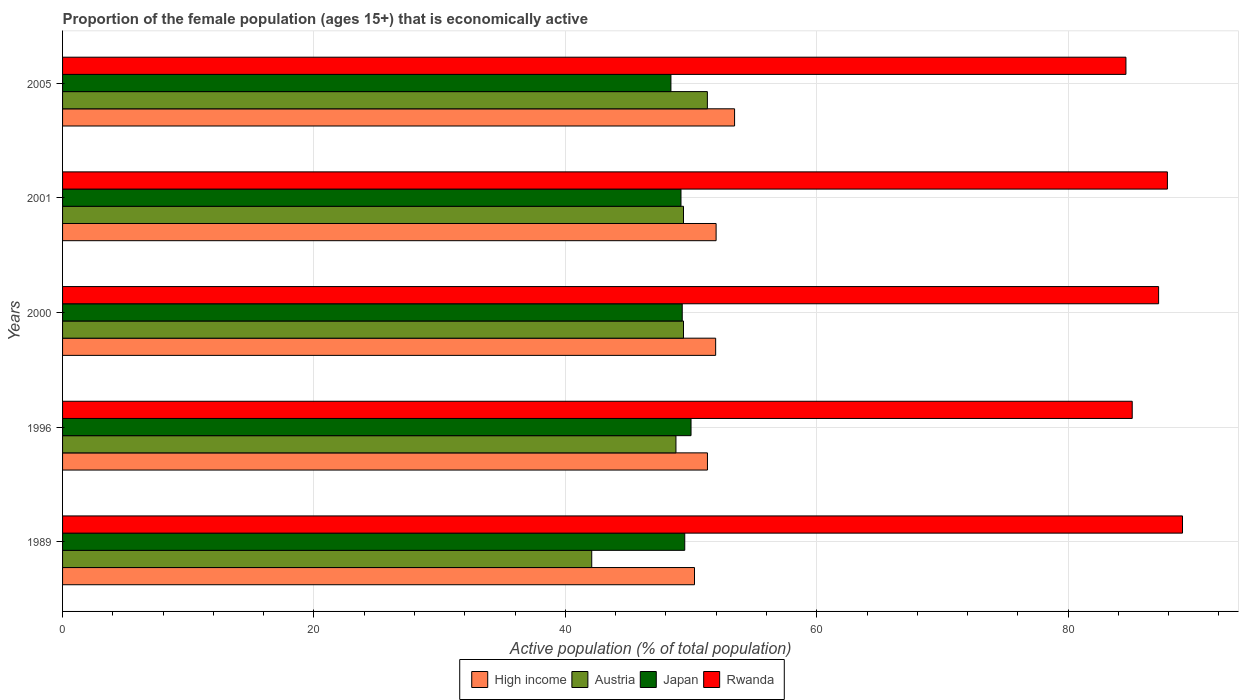How many different coloured bars are there?
Give a very brief answer. 4. How many bars are there on the 1st tick from the top?
Your response must be concise. 4. How many bars are there on the 5th tick from the bottom?
Offer a very short reply. 4. What is the proportion of the female population that is economically active in High income in 2000?
Ensure brevity in your answer.  51.96. Across all years, what is the maximum proportion of the female population that is economically active in Rwanda?
Offer a very short reply. 89.1. Across all years, what is the minimum proportion of the female population that is economically active in Rwanda?
Make the answer very short. 84.6. In which year was the proportion of the female population that is economically active in Austria maximum?
Give a very brief answer. 2005. What is the total proportion of the female population that is economically active in Austria in the graph?
Ensure brevity in your answer.  241. What is the difference between the proportion of the female population that is economically active in Austria in 1996 and that in 2000?
Make the answer very short. -0.6. What is the difference between the proportion of the female population that is economically active in Japan in 1996 and the proportion of the female population that is economically active in Rwanda in 1989?
Ensure brevity in your answer.  -39.1. What is the average proportion of the female population that is economically active in Austria per year?
Make the answer very short. 48.2. In the year 2000, what is the difference between the proportion of the female population that is economically active in High income and proportion of the female population that is economically active in Austria?
Your answer should be very brief. 2.56. In how many years, is the proportion of the female population that is economically active in Austria greater than 40 %?
Make the answer very short. 5. What is the ratio of the proportion of the female population that is economically active in High income in 1996 to that in 2001?
Your answer should be very brief. 0.99. Is the proportion of the female population that is economically active in High income in 2001 less than that in 2005?
Your answer should be compact. Yes. Is the difference between the proportion of the female population that is economically active in High income in 1996 and 2000 greater than the difference between the proportion of the female population that is economically active in Austria in 1996 and 2000?
Provide a short and direct response. No. What is the difference between the highest and the second highest proportion of the female population that is economically active in Rwanda?
Provide a short and direct response. 1.2. What is the difference between the highest and the lowest proportion of the female population that is economically active in Japan?
Your answer should be very brief. 1.6. In how many years, is the proportion of the female population that is economically active in Rwanda greater than the average proportion of the female population that is economically active in Rwanda taken over all years?
Offer a terse response. 3. Is it the case that in every year, the sum of the proportion of the female population that is economically active in Austria and proportion of the female population that is economically active in Japan is greater than the sum of proportion of the female population that is economically active in High income and proportion of the female population that is economically active in Rwanda?
Give a very brief answer. No. What does the 1st bar from the top in 2001 represents?
Give a very brief answer. Rwanda. What does the 3rd bar from the bottom in 1989 represents?
Give a very brief answer. Japan. Is it the case that in every year, the sum of the proportion of the female population that is economically active in Japan and proportion of the female population that is economically active in Rwanda is greater than the proportion of the female population that is economically active in High income?
Give a very brief answer. Yes. Are the values on the major ticks of X-axis written in scientific E-notation?
Ensure brevity in your answer.  No. How many legend labels are there?
Your answer should be very brief. 4. What is the title of the graph?
Provide a short and direct response. Proportion of the female population (ages 15+) that is economically active. Does "Gambia, The" appear as one of the legend labels in the graph?
Make the answer very short. No. What is the label or title of the X-axis?
Your answer should be compact. Active population (% of total population). What is the Active population (% of total population) in High income in 1989?
Provide a short and direct response. 50.28. What is the Active population (% of total population) in Austria in 1989?
Ensure brevity in your answer.  42.1. What is the Active population (% of total population) of Japan in 1989?
Your answer should be very brief. 49.5. What is the Active population (% of total population) in Rwanda in 1989?
Ensure brevity in your answer.  89.1. What is the Active population (% of total population) of High income in 1996?
Offer a terse response. 51.31. What is the Active population (% of total population) in Austria in 1996?
Keep it short and to the point. 48.8. What is the Active population (% of total population) of Rwanda in 1996?
Offer a terse response. 85.1. What is the Active population (% of total population) of High income in 2000?
Your answer should be very brief. 51.96. What is the Active population (% of total population) in Austria in 2000?
Your response must be concise. 49.4. What is the Active population (% of total population) of Japan in 2000?
Your answer should be compact. 49.3. What is the Active population (% of total population) in Rwanda in 2000?
Keep it short and to the point. 87.2. What is the Active population (% of total population) of High income in 2001?
Give a very brief answer. 51.99. What is the Active population (% of total population) of Austria in 2001?
Make the answer very short. 49.4. What is the Active population (% of total population) in Japan in 2001?
Offer a very short reply. 49.2. What is the Active population (% of total population) of Rwanda in 2001?
Provide a short and direct response. 87.9. What is the Active population (% of total population) of High income in 2005?
Your response must be concise. 53.46. What is the Active population (% of total population) in Austria in 2005?
Offer a very short reply. 51.3. What is the Active population (% of total population) of Japan in 2005?
Ensure brevity in your answer.  48.4. What is the Active population (% of total population) of Rwanda in 2005?
Offer a terse response. 84.6. Across all years, what is the maximum Active population (% of total population) of High income?
Your answer should be compact. 53.46. Across all years, what is the maximum Active population (% of total population) of Austria?
Ensure brevity in your answer.  51.3. Across all years, what is the maximum Active population (% of total population) of Rwanda?
Offer a very short reply. 89.1. Across all years, what is the minimum Active population (% of total population) in High income?
Provide a short and direct response. 50.28. Across all years, what is the minimum Active population (% of total population) of Austria?
Ensure brevity in your answer.  42.1. Across all years, what is the minimum Active population (% of total population) of Japan?
Offer a very short reply. 48.4. Across all years, what is the minimum Active population (% of total population) in Rwanda?
Make the answer very short. 84.6. What is the total Active population (% of total population) of High income in the graph?
Ensure brevity in your answer.  259. What is the total Active population (% of total population) in Austria in the graph?
Provide a short and direct response. 241. What is the total Active population (% of total population) of Japan in the graph?
Provide a succinct answer. 246.4. What is the total Active population (% of total population) in Rwanda in the graph?
Offer a very short reply. 433.9. What is the difference between the Active population (% of total population) of High income in 1989 and that in 1996?
Provide a succinct answer. -1.03. What is the difference between the Active population (% of total population) in Austria in 1989 and that in 1996?
Keep it short and to the point. -6.7. What is the difference between the Active population (% of total population) of High income in 1989 and that in 2000?
Offer a terse response. -1.68. What is the difference between the Active population (% of total population) in Rwanda in 1989 and that in 2000?
Make the answer very short. 1.9. What is the difference between the Active population (% of total population) in High income in 1989 and that in 2001?
Offer a very short reply. -1.72. What is the difference between the Active population (% of total population) in Austria in 1989 and that in 2001?
Your response must be concise. -7.3. What is the difference between the Active population (% of total population) in High income in 1989 and that in 2005?
Keep it short and to the point. -3.19. What is the difference between the Active population (% of total population) of Austria in 1989 and that in 2005?
Keep it short and to the point. -9.2. What is the difference between the Active population (% of total population) in Japan in 1989 and that in 2005?
Provide a succinct answer. 1.1. What is the difference between the Active population (% of total population) in High income in 1996 and that in 2000?
Your response must be concise. -0.65. What is the difference between the Active population (% of total population) in Austria in 1996 and that in 2000?
Ensure brevity in your answer.  -0.6. What is the difference between the Active population (% of total population) of Japan in 1996 and that in 2000?
Your answer should be compact. 0.7. What is the difference between the Active population (% of total population) of High income in 1996 and that in 2001?
Your answer should be compact. -0.69. What is the difference between the Active population (% of total population) of Austria in 1996 and that in 2001?
Make the answer very short. -0.6. What is the difference between the Active population (% of total population) of Japan in 1996 and that in 2001?
Give a very brief answer. 0.8. What is the difference between the Active population (% of total population) of High income in 1996 and that in 2005?
Offer a very short reply. -2.16. What is the difference between the Active population (% of total population) of Austria in 1996 and that in 2005?
Keep it short and to the point. -2.5. What is the difference between the Active population (% of total population) of Rwanda in 1996 and that in 2005?
Provide a succinct answer. 0.5. What is the difference between the Active population (% of total population) of High income in 2000 and that in 2001?
Provide a succinct answer. -0.04. What is the difference between the Active population (% of total population) in Austria in 2000 and that in 2001?
Offer a very short reply. 0. What is the difference between the Active population (% of total population) in Rwanda in 2000 and that in 2001?
Offer a very short reply. -0.7. What is the difference between the Active population (% of total population) of High income in 2000 and that in 2005?
Your answer should be very brief. -1.51. What is the difference between the Active population (% of total population) of High income in 2001 and that in 2005?
Give a very brief answer. -1.47. What is the difference between the Active population (% of total population) of High income in 1989 and the Active population (% of total population) of Austria in 1996?
Your answer should be compact. 1.48. What is the difference between the Active population (% of total population) in High income in 1989 and the Active population (% of total population) in Japan in 1996?
Provide a succinct answer. 0.28. What is the difference between the Active population (% of total population) of High income in 1989 and the Active population (% of total population) of Rwanda in 1996?
Provide a succinct answer. -34.82. What is the difference between the Active population (% of total population) in Austria in 1989 and the Active population (% of total population) in Japan in 1996?
Give a very brief answer. -7.9. What is the difference between the Active population (% of total population) of Austria in 1989 and the Active population (% of total population) of Rwanda in 1996?
Your response must be concise. -43. What is the difference between the Active population (% of total population) of Japan in 1989 and the Active population (% of total population) of Rwanda in 1996?
Ensure brevity in your answer.  -35.6. What is the difference between the Active population (% of total population) in High income in 1989 and the Active population (% of total population) in Austria in 2000?
Provide a succinct answer. 0.88. What is the difference between the Active population (% of total population) of High income in 1989 and the Active population (% of total population) of Japan in 2000?
Provide a succinct answer. 0.98. What is the difference between the Active population (% of total population) in High income in 1989 and the Active population (% of total population) in Rwanda in 2000?
Your answer should be compact. -36.92. What is the difference between the Active population (% of total population) in Austria in 1989 and the Active population (% of total population) in Rwanda in 2000?
Ensure brevity in your answer.  -45.1. What is the difference between the Active population (% of total population) of Japan in 1989 and the Active population (% of total population) of Rwanda in 2000?
Ensure brevity in your answer.  -37.7. What is the difference between the Active population (% of total population) of High income in 1989 and the Active population (% of total population) of Austria in 2001?
Your response must be concise. 0.88. What is the difference between the Active population (% of total population) in High income in 1989 and the Active population (% of total population) in Japan in 2001?
Give a very brief answer. 1.08. What is the difference between the Active population (% of total population) in High income in 1989 and the Active population (% of total population) in Rwanda in 2001?
Make the answer very short. -37.62. What is the difference between the Active population (% of total population) in Austria in 1989 and the Active population (% of total population) in Japan in 2001?
Provide a short and direct response. -7.1. What is the difference between the Active population (% of total population) in Austria in 1989 and the Active population (% of total population) in Rwanda in 2001?
Provide a short and direct response. -45.8. What is the difference between the Active population (% of total population) of Japan in 1989 and the Active population (% of total population) of Rwanda in 2001?
Give a very brief answer. -38.4. What is the difference between the Active population (% of total population) of High income in 1989 and the Active population (% of total population) of Austria in 2005?
Your response must be concise. -1.02. What is the difference between the Active population (% of total population) of High income in 1989 and the Active population (% of total population) of Japan in 2005?
Ensure brevity in your answer.  1.88. What is the difference between the Active population (% of total population) of High income in 1989 and the Active population (% of total population) of Rwanda in 2005?
Provide a short and direct response. -34.32. What is the difference between the Active population (% of total population) of Austria in 1989 and the Active population (% of total population) of Rwanda in 2005?
Your answer should be compact. -42.5. What is the difference between the Active population (% of total population) of Japan in 1989 and the Active population (% of total population) of Rwanda in 2005?
Keep it short and to the point. -35.1. What is the difference between the Active population (% of total population) of High income in 1996 and the Active population (% of total population) of Austria in 2000?
Make the answer very short. 1.91. What is the difference between the Active population (% of total population) of High income in 1996 and the Active population (% of total population) of Japan in 2000?
Give a very brief answer. 2.01. What is the difference between the Active population (% of total population) in High income in 1996 and the Active population (% of total population) in Rwanda in 2000?
Your answer should be very brief. -35.89. What is the difference between the Active population (% of total population) in Austria in 1996 and the Active population (% of total population) in Rwanda in 2000?
Your answer should be very brief. -38.4. What is the difference between the Active population (% of total population) of Japan in 1996 and the Active population (% of total population) of Rwanda in 2000?
Make the answer very short. -37.2. What is the difference between the Active population (% of total population) in High income in 1996 and the Active population (% of total population) in Austria in 2001?
Offer a very short reply. 1.91. What is the difference between the Active population (% of total population) in High income in 1996 and the Active population (% of total population) in Japan in 2001?
Your response must be concise. 2.11. What is the difference between the Active population (% of total population) in High income in 1996 and the Active population (% of total population) in Rwanda in 2001?
Offer a very short reply. -36.59. What is the difference between the Active population (% of total population) of Austria in 1996 and the Active population (% of total population) of Rwanda in 2001?
Provide a succinct answer. -39.1. What is the difference between the Active population (% of total population) in Japan in 1996 and the Active population (% of total population) in Rwanda in 2001?
Give a very brief answer. -37.9. What is the difference between the Active population (% of total population) of High income in 1996 and the Active population (% of total population) of Austria in 2005?
Offer a very short reply. 0.01. What is the difference between the Active population (% of total population) of High income in 1996 and the Active population (% of total population) of Japan in 2005?
Make the answer very short. 2.91. What is the difference between the Active population (% of total population) of High income in 1996 and the Active population (% of total population) of Rwanda in 2005?
Offer a terse response. -33.29. What is the difference between the Active population (% of total population) of Austria in 1996 and the Active population (% of total population) of Japan in 2005?
Give a very brief answer. 0.4. What is the difference between the Active population (% of total population) in Austria in 1996 and the Active population (% of total population) in Rwanda in 2005?
Provide a succinct answer. -35.8. What is the difference between the Active population (% of total population) in Japan in 1996 and the Active population (% of total population) in Rwanda in 2005?
Give a very brief answer. -34.6. What is the difference between the Active population (% of total population) in High income in 2000 and the Active population (% of total population) in Austria in 2001?
Offer a very short reply. 2.56. What is the difference between the Active population (% of total population) in High income in 2000 and the Active population (% of total population) in Japan in 2001?
Give a very brief answer. 2.76. What is the difference between the Active population (% of total population) in High income in 2000 and the Active population (% of total population) in Rwanda in 2001?
Keep it short and to the point. -35.94. What is the difference between the Active population (% of total population) of Austria in 2000 and the Active population (% of total population) of Japan in 2001?
Give a very brief answer. 0.2. What is the difference between the Active population (% of total population) of Austria in 2000 and the Active population (% of total population) of Rwanda in 2001?
Make the answer very short. -38.5. What is the difference between the Active population (% of total population) of Japan in 2000 and the Active population (% of total population) of Rwanda in 2001?
Make the answer very short. -38.6. What is the difference between the Active population (% of total population) in High income in 2000 and the Active population (% of total population) in Austria in 2005?
Make the answer very short. 0.66. What is the difference between the Active population (% of total population) in High income in 2000 and the Active population (% of total population) in Japan in 2005?
Provide a short and direct response. 3.56. What is the difference between the Active population (% of total population) of High income in 2000 and the Active population (% of total population) of Rwanda in 2005?
Ensure brevity in your answer.  -32.64. What is the difference between the Active population (% of total population) of Austria in 2000 and the Active population (% of total population) of Japan in 2005?
Give a very brief answer. 1. What is the difference between the Active population (% of total population) in Austria in 2000 and the Active population (% of total population) in Rwanda in 2005?
Provide a succinct answer. -35.2. What is the difference between the Active population (% of total population) in Japan in 2000 and the Active population (% of total population) in Rwanda in 2005?
Offer a terse response. -35.3. What is the difference between the Active population (% of total population) of High income in 2001 and the Active population (% of total population) of Austria in 2005?
Make the answer very short. 0.69. What is the difference between the Active population (% of total population) of High income in 2001 and the Active population (% of total population) of Japan in 2005?
Ensure brevity in your answer.  3.59. What is the difference between the Active population (% of total population) of High income in 2001 and the Active population (% of total population) of Rwanda in 2005?
Your answer should be very brief. -32.61. What is the difference between the Active population (% of total population) in Austria in 2001 and the Active population (% of total population) in Japan in 2005?
Ensure brevity in your answer.  1. What is the difference between the Active population (% of total population) in Austria in 2001 and the Active population (% of total population) in Rwanda in 2005?
Keep it short and to the point. -35.2. What is the difference between the Active population (% of total population) of Japan in 2001 and the Active population (% of total population) of Rwanda in 2005?
Make the answer very short. -35.4. What is the average Active population (% of total population) in High income per year?
Your answer should be very brief. 51.8. What is the average Active population (% of total population) of Austria per year?
Your response must be concise. 48.2. What is the average Active population (% of total population) of Japan per year?
Make the answer very short. 49.28. What is the average Active population (% of total population) in Rwanda per year?
Give a very brief answer. 86.78. In the year 1989, what is the difference between the Active population (% of total population) of High income and Active population (% of total population) of Austria?
Ensure brevity in your answer.  8.18. In the year 1989, what is the difference between the Active population (% of total population) in High income and Active population (% of total population) in Japan?
Give a very brief answer. 0.78. In the year 1989, what is the difference between the Active population (% of total population) in High income and Active population (% of total population) in Rwanda?
Offer a terse response. -38.82. In the year 1989, what is the difference between the Active population (% of total population) of Austria and Active population (% of total population) of Rwanda?
Provide a succinct answer. -47. In the year 1989, what is the difference between the Active population (% of total population) in Japan and Active population (% of total population) in Rwanda?
Offer a very short reply. -39.6. In the year 1996, what is the difference between the Active population (% of total population) in High income and Active population (% of total population) in Austria?
Your answer should be very brief. 2.51. In the year 1996, what is the difference between the Active population (% of total population) in High income and Active population (% of total population) in Japan?
Offer a terse response. 1.31. In the year 1996, what is the difference between the Active population (% of total population) of High income and Active population (% of total population) of Rwanda?
Keep it short and to the point. -33.79. In the year 1996, what is the difference between the Active population (% of total population) in Austria and Active population (% of total population) in Japan?
Provide a succinct answer. -1.2. In the year 1996, what is the difference between the Active population (% of total population) of Austria and Active population (% of total population) of Rwanda?
Offer a terse response. -36.3. In the year 1996, what is the difference between the Active population (% of total population) in Japan and Active population (% of total population) in Rwanda?
Offer a very short reply. -35.1. In the year 2000, what is the difference between the Active population (% of total population) in High income and Active population (% of total population) in Austria?
Make the answer very short. 2.56. In the year 2000, what is the difference between the Active population (% of total population) of High income and Active population (% of total population) of Japan?
Ensure brevity in your answer.  2.66. In the year 2000, what is the difference between the Active population (% of total population) in High income and Active population (% of total population) in Rwanda?
Keep it short and to the point. -35.24. In the year 2000, what is the difference between the Active population (% of total population) in Austria and Active population (% of total population) in Rwanda?
Your answer should be compact. -37.8. In the year 2000, what is the difference between the Active population (% of total population) of Japan and Active population (% of total population) of Rwanda?
Make the answer very short. -37.9. In the year 2001, what is the difference between the Active population (% of total population) of High income and Active population (% of total population) of Austria?
Offer a terse response. 2.59. In the year 2001, what is the difference between the Active population (% of total population) of High income and Active population (% of total population) of Japan?
Your answer should be compact. 2.79. In the year 2001, what is the difference between the Active population (% of total population) in High income and Active population (% of total population) in Rwanda?
Provide a short and direct response. -35.91. In the year 2001, what is the difference between the Active population (% of total population) in Austria and Active population (% of total population) in Rwanda?
Keep it short and to the point. -38.5. In the year 2001, what is the difference between the Active population (% of total population) in Japan and Active population (% of total population) in Rwanda?
Provide a succinct answer. -38.7. In the year 2005, what is the difference between the Active population (% of total population) of High income and Active population (% of total population) of Austria?
Ensure brevity in your answer.  2.16. In the year 2005, what is the difference between the Active population (% of total population) in High income and Active population (% of total population) in Japan?
Ensure brevity in your answer.  5.06. In the year 2005, what is the difference between the Active population (% of total population) in High income and Active population (% of total population) in Rwanda?
Your answer should be compact. -31.14. In the year 2005, what is the difference between the Active population (% of total population) in Austria and Active population (% of total population) in Japan?
Make the answer very short. 2.9. In the year 2005, what is the difference between the Active population (% of total population) in Austria and Active population (% of total population) in Rwanda?
Ensure brevity in your answer.  -33.3. In the year 2005, what is the difference between the Active population (% of total population) in Japan and Active population (% of total population) in Rwanda?
Make the answer very short. -36.2. What is the ratio of the Active population (% of total population) in High income in 1989 to that in 1996?
Your answer should be very brief. 0.98. What is the ratio of the Active population (% of total population) in Austria in 1989 to that in 1996?
Give a very brief answer. 0.86. What is the ratio of the Active population (% of total population) of Rwanda in 1989 to that in 1996?
Provide a succinct answer. 1.05. What is the ratio of the Active population (% of total population) in High income in 1989 to that in 2000?
Your response must be concise. 0.97. What is the ratio of the Active population (% of total population) in Austria in 1989 to that in 2000?
Your answer should be very brief. 0.85. What is the ratio of the Active population (% of total population) of Japan in 1989 to that in 2000?
Provide a short and direct response. 1. What is the ratio of the Active population (% of total population) of Rwanda in 1989 to that in 2000?
Ensure brevity in your answer.  1.02. What is the ratio of the Active population (% of total population) in High income in 1989 to that in 2001?
Provide a succinct answer. 0.97. What is the ratio of the Active population (% of total population) of Austria in 1989 to that in 2001?
Your answer should be very brief. 0.85. What is the ratio of the Active population (% of total population) of Japan in 1989 to that in 2001?
Make the answer very short. 1.01. What is the ratio of the Active population (% of total population) of Rwanda in 1989 to that in 2001?
Your answer should be compact. 1.01. What is the ratio of the Active population (% of total population) in High income in 1989 to that in 2005?
Make the answer very short. 0.94. What is the ratio of the Active population (% of total population) in Austria in 1989 to that in 2005?
Your answer should be very brief. 0.82. What is the ratio of the Active population (% of total population) of Japan in 1989 to that in 2005?
Make the answer very short. 1.02. What is the ratio of the Active population (% of total population) in Rwanda in 1989 to that in 2005?
Offer a very short reply. 1.05. What is the ratio of the Active population (% of total population) in High income in 1996 to that in 2000?
Offer a terse response. 0.99. What is the ratio of the Active population (% of total population) in Austria in 1996 to that in 2000?
Your response must be concise. 0.99. What is the ratio of the Active population (% of total population) in Japan in 1996 to that in 2000?
Provide a succinct answer. 1.01. What is the ratio of the Active population (% of total population) of Rwanda in 1996 to that in 2000?
Your answer should be very brief. 0.98. What is the ratio of the Active population (% of total population) of Austria in 1996 to that in 2001?
Your answer should be compact. 0.99. What is the ratio of the Active population (% of total population) of Japan in 1996 to that in 2001?
Offer a terse response. 1.02. What is the ratio of the Active population (% of total population) in Rwanda in 1996 to that in 2001?
Provide a short and direct response. 0.97. What is the ratio of the Active population (% of total population) in High income in 1996 to that in 2005?
Offer a terse response. 0.96. What is the ratio of the Active population (% of total population) of Austria in 1996 to that in 2005?
Offer a very short reply. 0.95. What is the ratio of the Active population (% of total population) of Japan in 1996 to that in 2005?
Offer a very short reply. 1.03. What is the ratio of the Active population (% of total population) of Rwanda in 1996 to that in 2005?
Ensure brevity in your answer.  1.01. What is the ratio of the Active population (% of total population) in Japan in 2000 to that in 2001?
Make the answer very short. 1. What is the ratio of the Active population (% of total population) in Rwanda in 2000 to that in 2001?
Keep it short and to the point. 0.99. What is the ratio of the Active population (% of total population) of High income in 2000 to that in 2005?
Offer a very short reply. 0.97. What is the ratio of the Active population (% of total population) of Austria in 2000 to that in 2005?
Give a very brief answer. 0.96. What is the ratio of the Active population (% of total population) in Japan in 2000 to that in 2005?
Offer a very short reply. 1.02. What is the ratio of the Active population (% of total population) of Rwanda in 2000 to that in 2005?
Your answer should be very brief. 1.03. What is the ratio of the Active population (% of total population) in High income in 2001 to that in 2005?
Your response must be concise. 0.97. What is the ratio of the Active population (% of total population) of Austria in 2001 to that in 2005?
Keep it short and to the point. 0.96. What is the ratio of the Active population (% of total population) in Japan in 2001 to that in 2005?
Your answer should be compact. 1.02. What is the ratio of the Active population (% of total population) in Rwanda in 2001 to that in 2005?
Keep it short and to the point. 1.04. What is the difference between the highest and the second highest Active population (% of total population) in High income?
Your response must be concise. 1.47. What is the difference between the highest and the second highest Active population (% of total population) in Japan?
Provide a succinct answer. 0.5. What is the difference between the highest and the lowest Active population (% of total population) in High income?
Your answer should be compact. 3.19. What is the difference between the highest and the lowest Active population (% of total population) in Austria?
Ensure brevity in your answer.  9.2. What is the difference between the highest and the lowest Active population (% of total population) of Japan?
Your answer should be compact. 1.6. What is the difference between the highest and the lowest Active population (% of total population) in Rwanda?
Make the answer very short. 4.5. 